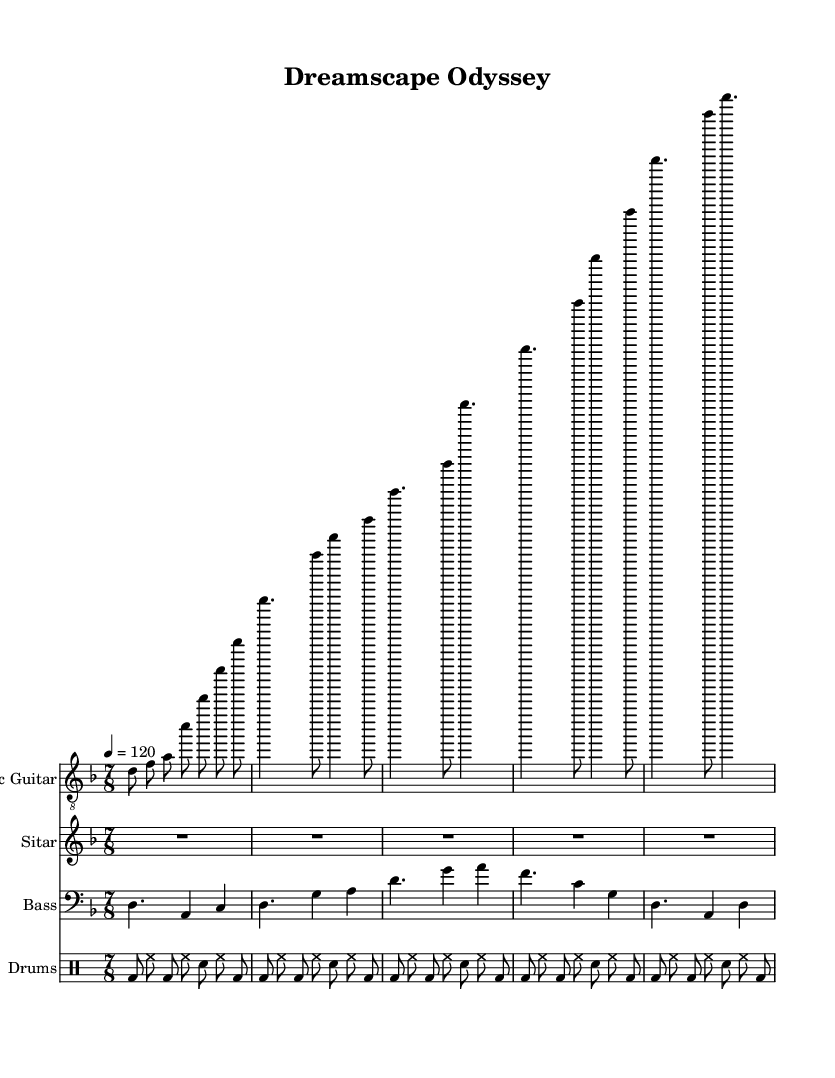What is the key signature of this music? The key signature shows one flat, indicating it is in D minor.
Answer: D minor What is the time signature of the piece? The time signature is indicated at the beginning of the score and shows it is in 7/8.
Answer: 7/8 What is the tempo marking for this music? The tempo marking indicates a quarter note equals 120 beats per minute, which can be found in the tempo instruction at the top of the score.
Answer: 120 How many measures are in the verse section of the electric guitar part? The verse section is shown with two measures in the electric guitar notation, which can be counted in the measures between the intro and the chorus.
Answer: 2 Which two instruments play the same rhythm in the intro section? In the intro, both the electric guitar and drums share a similar rhythmic pattern as they begin the piece, allowing for an easily recognizable start.
Answer: Electric guitar and drums What is the primary role of the sitar in this composition? The sitar serves as a rhythmic filler throughout the sections, playing rests during the introduction and chorus, which contributes to the ethereal sound characteristic of fusion music.
Answer: Rhythmic filler How many beats are in each measure of the bass guitar part? Each measure in the bass guitar part corresponds with the 7/8 time signature, indicating there are seven beats per measure as specified by the time signature.
Answer: 7 beats 